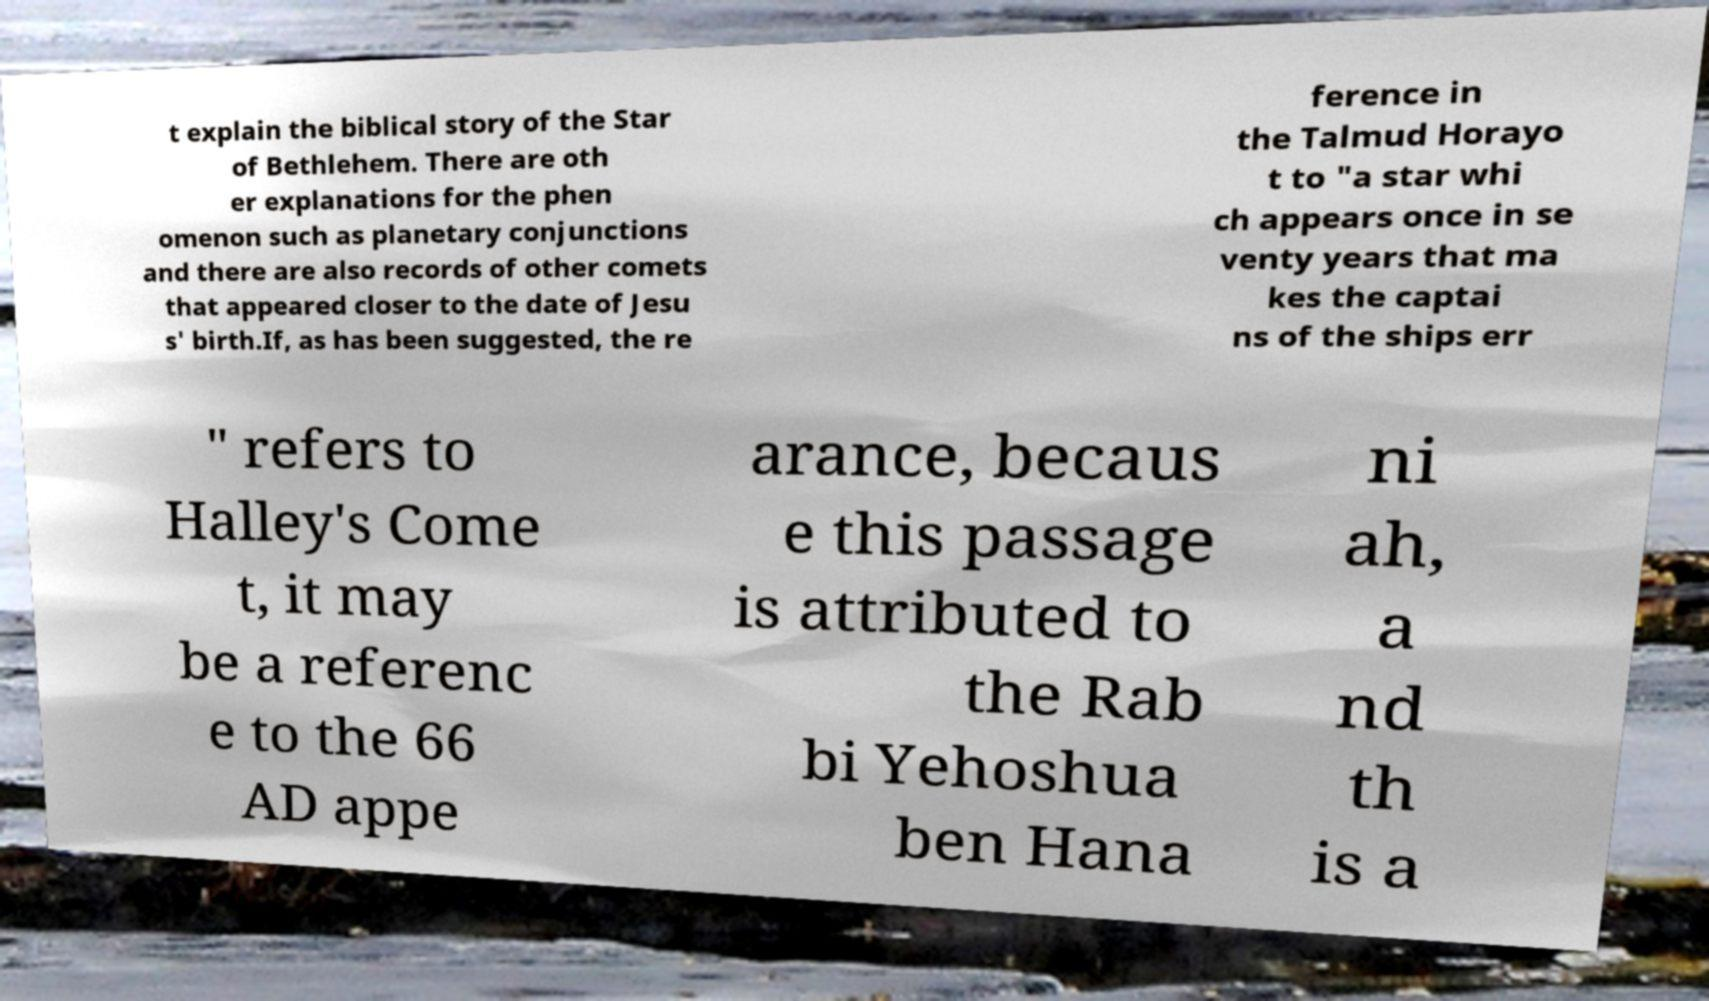What messages or text are displayed in this image? I need them in a readable, typed format. t explain the biblical story of the Star of Bethlehem. There are oth er explanations for the phen omenon such as planetary conjunctions and there are also records of other comets that appeared closer to the date of Jesu s' birth.If, as has been suggested, the re ference in the Talmud Horayo t to "a star whi ch appears once in se venty years that ma kes the captai ns of the ships err " refers to Halley's Come t, it may be a referenc e to the 66 AD appe arance, becaus e this passage is attributed to the Rab bi Yehoshua ben Hana ni ah, a nd th is a 